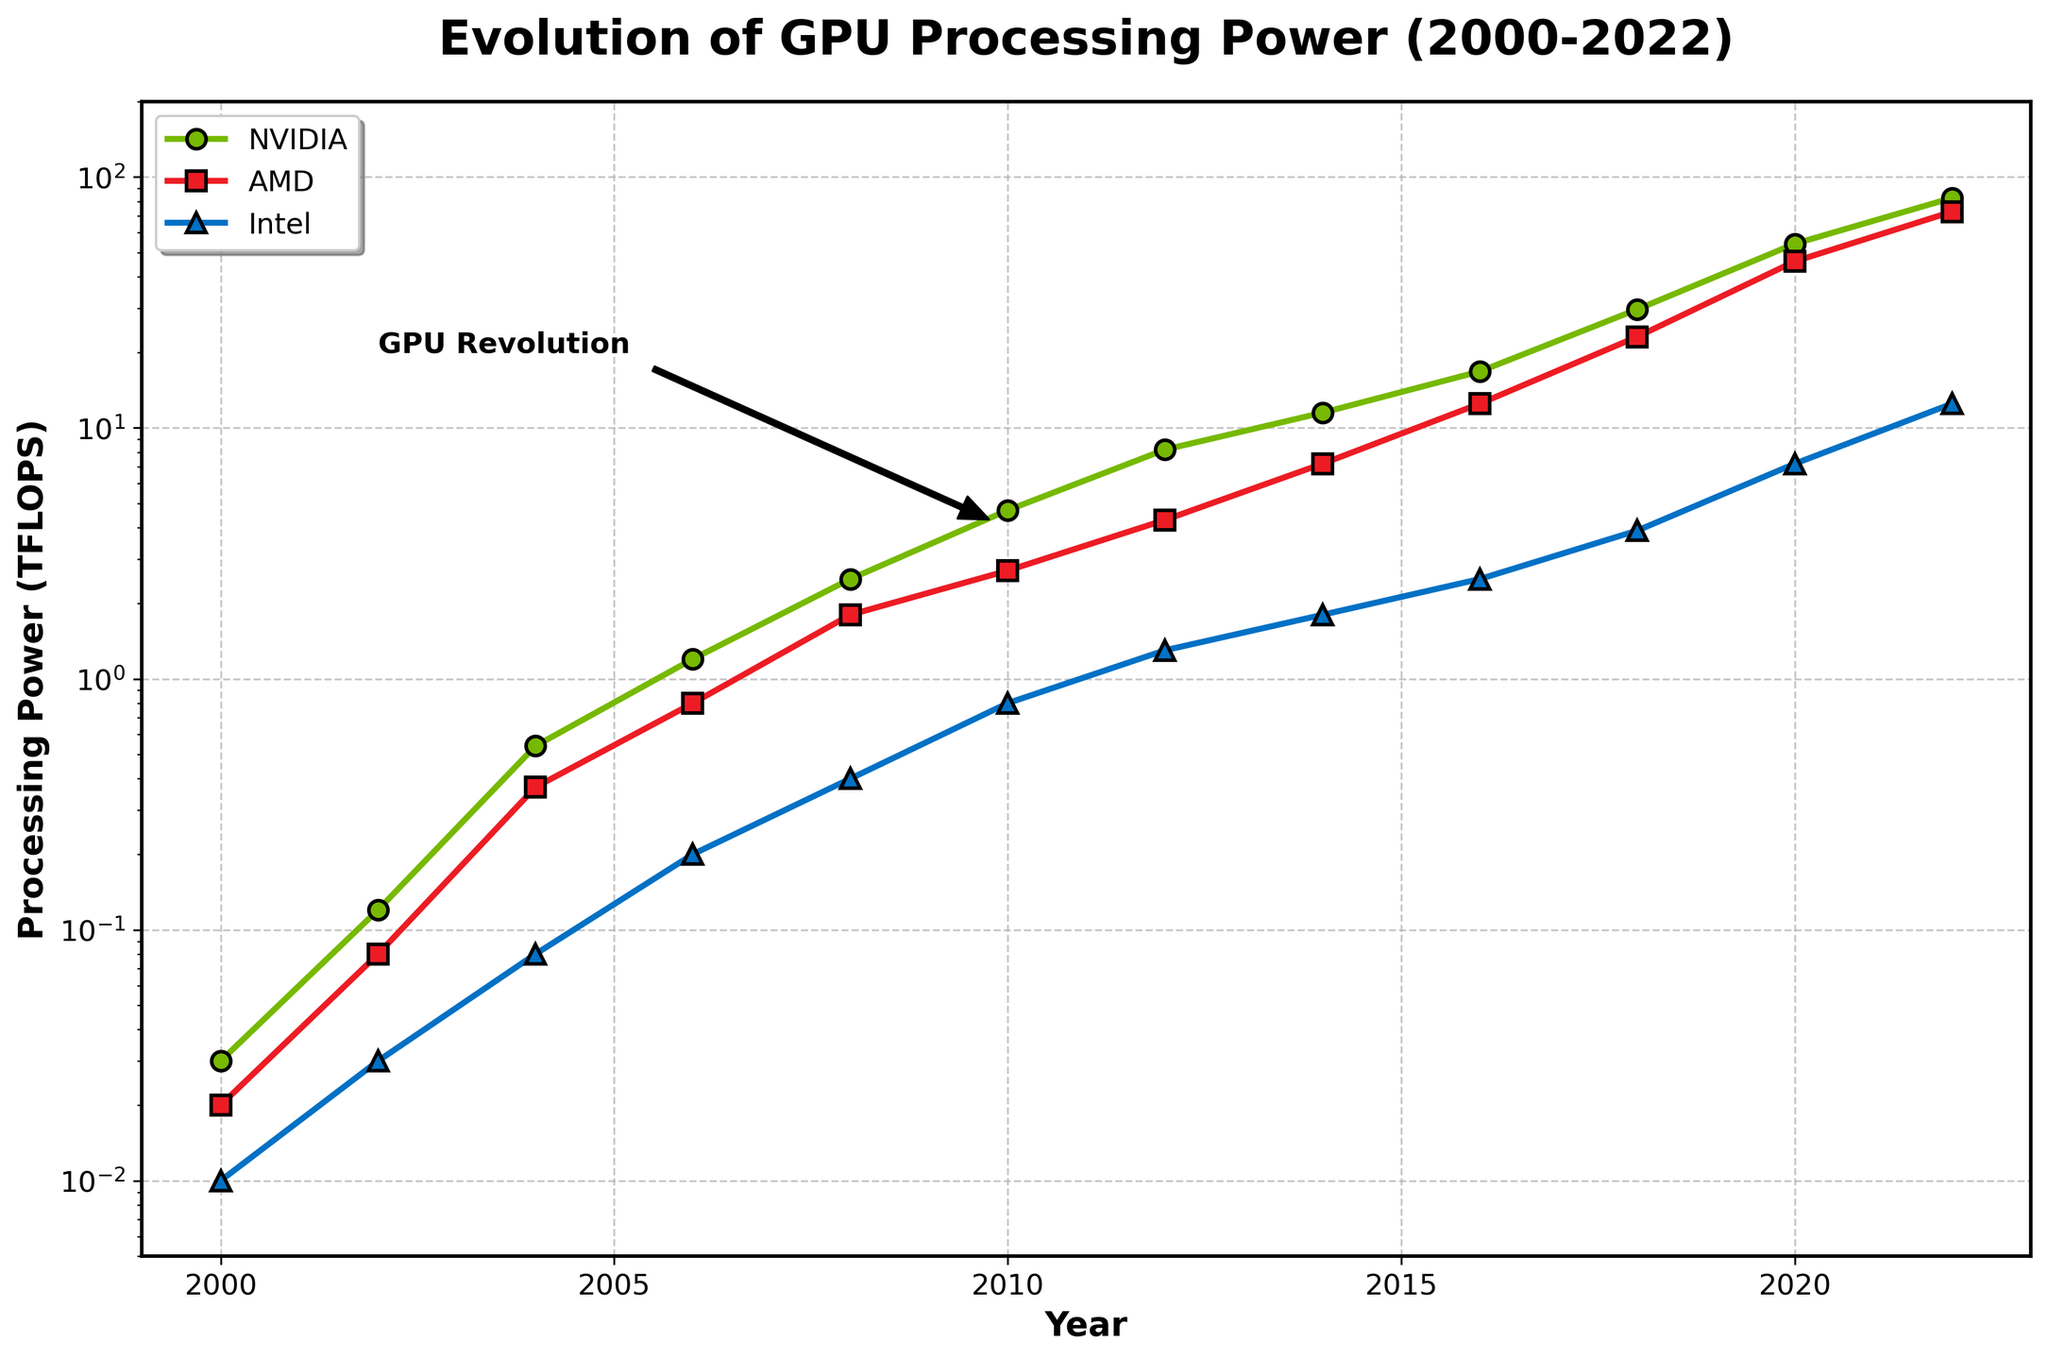Which company showed the highest GPU processing power in 2022? The graph shows the processing power in 2022 on the y-axis. By looking at the data points for 2022, NVIDIA is at the highest value of approximately 82.6 TFLOPS.
Answer: NVIDIA What was the trend in AMD's GPU processing power between 2000 and 2022? Reviewing the data points for AMD from 2000 to 2022 on the graph, there is a consistent upward trend in the processing power, rising from 0.02 TFLOPS to approximately 72.8 TFLOPS.
Answer: Upward trend Compare the GPU processing power of NVIDIA and AMD in 2018. Which company had more, and by how much? In 2018, the data points show NVIDIA at 29.7 TFLOPS and AMD at 23.1 TFLOPS. The difference is calculated as 29.7 - 23.1.
Answer: NVIDIA by 6.6 TFLOPS In which year did Intel's GPU processing power first exceed 1 TFLOP? By observing Intel's data points, Intel's GPU processing power first exceeds 1 TFLOP in 2012, where it reaches 1.3 TFLOPS.
Answer: 2012 What is the average GPU processing power of AMD in the first half of the timeline (2000-2010)? Summing AMD's values from 2000 to 2010: 0.02+0.08+0.37+0.8+1.8+2.7=5.77. Dividing by the number of years (6) gives the average: 5.77/6.
Answer: 0.96 TFLOPS What is the visual difference between NVIDIA's GPU processing power in 2006 and 2020? Looking at the markers for NVIDIA in 2006 and 2020, there is a significant increase in height, with 2006 at around 1.2 TFLOPS and 2020 at approximately 54.2 TFLOPS, indicating a steep rise.
Answer: Significant increase Which company had the smallest processing power growth between 2018 and 2022? By comparing the differences in 2018 vs 2022 for each company: 
NVIDIA: 82.6-29.7 = 52.9, 
AMD: 72.8-23.1 = 49.7, 
Intel: 12.5-3.9 = 8.6. 
Intel had the smallest growth.
Answer: Intel Among NVIDIA, AMD, and Intel, which company showed the steepest increase in GPU processing power from 2000 to 2022? By comparing the initial and final values: 
NVIDIA: 82.6-0.03 = 82.57, 
AMD: 72.8-0.02 = 72.78, 
Intel: 12.5-0.01 = 12.49. 
NVIDIA shows the steepest increase.
Answer: NVIDIA In which year did NVIDIA's GPU processing power reach the milestone of 10 TFLOPS? Looking at the NVIDIA data points, it exceeded 10 TFLOPS between 2012 (8.2) and 2014 (11.5).
Answer: 2014 